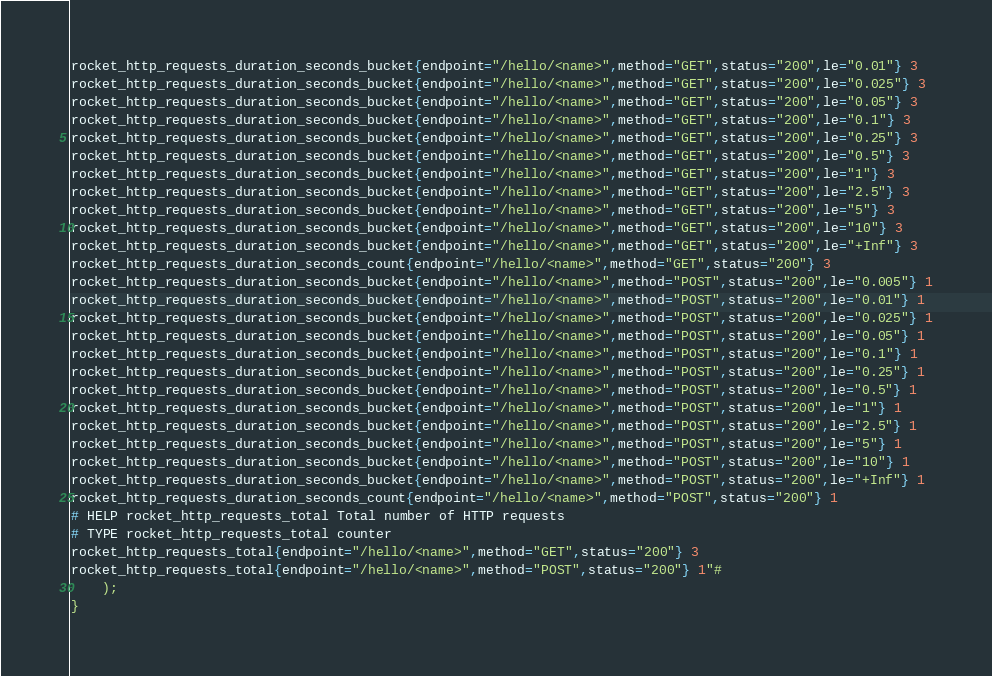Convert code to text. <code><loc_0><loc_0><loc_500><loc_500><_Rust_>rocket_http_requests_duration_seconds_bucket{endpoint="/hello/<name>",method="GET",status="200",le="0.01"} 3
rocket_http_requests_duration_seconds_bucket{endpoint="/hello/<name>",method="GET",status="200",le="0.025"} 3
rocket_http_requests_duration_seconds_bucket{endpoint="/hello/<name>",method="GET",status="200",le="0.05"} 3
rocket_http_requests_duration_seconds_bucket{endpoint="/hello/<name>",method="GET",status="200",le="0.1"} 3
rocket_http_requests_duration_seconds_bucket{endpoint="/hello/<name>",method="GET",status="200",le="0.25"} 3
rocket_http_requests_duration_seconds_bucket{endpoint="/hello/<name>",method="GET",status="200",le="0.5"} 3
rocket_http_requests_duration_seconds_bucket{endpoint="/hello/<name>",method="GET",status="200",le="1"} 3
rocket_http_requests_duration_seconds_bucket{endpoint="/hello/<name>",method="GET",status="200",le="2.5"} 3
rocket_http_requests_duration_seconds_bucket{endpoint="/hello/<name>",method="GET",status="200",le="5"} 3
rocket_http_requests_duration_seconds_bucket{endpoint="/hello/<name>",method="GET",status="200",le="10"} 3
rocket_http_requests_duration_seconds_bucket{endpoint="/hello/<name>",method="GET",status="200",le="+Inf"} 3
rocket_http_requests_duration_seconds_count{endpoint="/hello/<name>",method="GET",status="200"} 3
rocket_http_requests_duration_seconds_bucket{endpoint="/hello/<name>",method="POST",status="200",le="0.005"} 1
rocket_http_requests_duration_seconds_bucket{endpoint="/hello/<name>",method="POST",status="200",le="0.01"} 1
rocket_http_requests_duration_seconds_bucket{endpoint="/hello/<name>",method="POST",status="200",le="0.025"} 1
rocket_http_requests_duration_seconds_bucket{endpoint="/hello/<name>",method="POST",status="200",le="0.05"} 1
rocket_http_requests_duration_seconds_bucket{endpoint="/hello/<name>",method="POST",status="200",le="0.1"} 1
rocket_http_requests_duration_seconds_bucket{endpoint="/hello/<name>",method="POST",status="200",le="0.25"} 1
rocket_http_requests_duration_seconds_bucket{endpoint="/hello/<name>",method="POST",status="200",le="0.5"} 1
rocket_http_requests_duration_seconds_bucket{endpoint="/hello/<name>",method="POST",status="200",le="1"} 1
rocket_http_requests_duration_seconds_bucket{endpoint="/hello/<name>",method="POST",status="200",le="2.5"} 1
rocket_http_requests_duration_seconds_bucket{endpoint="/hello/<name>",method="POST",status="200",le="5"} 1
rocket_http_requests_duration_seconds_bucket{endpoint="/hello/<name>",method="POST",status="200",le="10"} 1
rocket_http_requests_duration_seconds_bucket{endpoint="/hello/<name>",method="POST",status="200",le="+Inf"} 1
rocket_http_requests_duration_seconds_count{endpoint="/hello/<name>",method="POST",status="200"} 1
# HELP rocket_http_requests_total Total number of HTTP requests
# TYPE rocket_http_requests_total counter
rocket_http_requests_total{endpoint="/hello/<name>",method="GET",status="200"} 3
rocket_http_requests_total{endpoint="/hello/<name>",method="POST",status="200"} 1"#
    );
}
</code> 